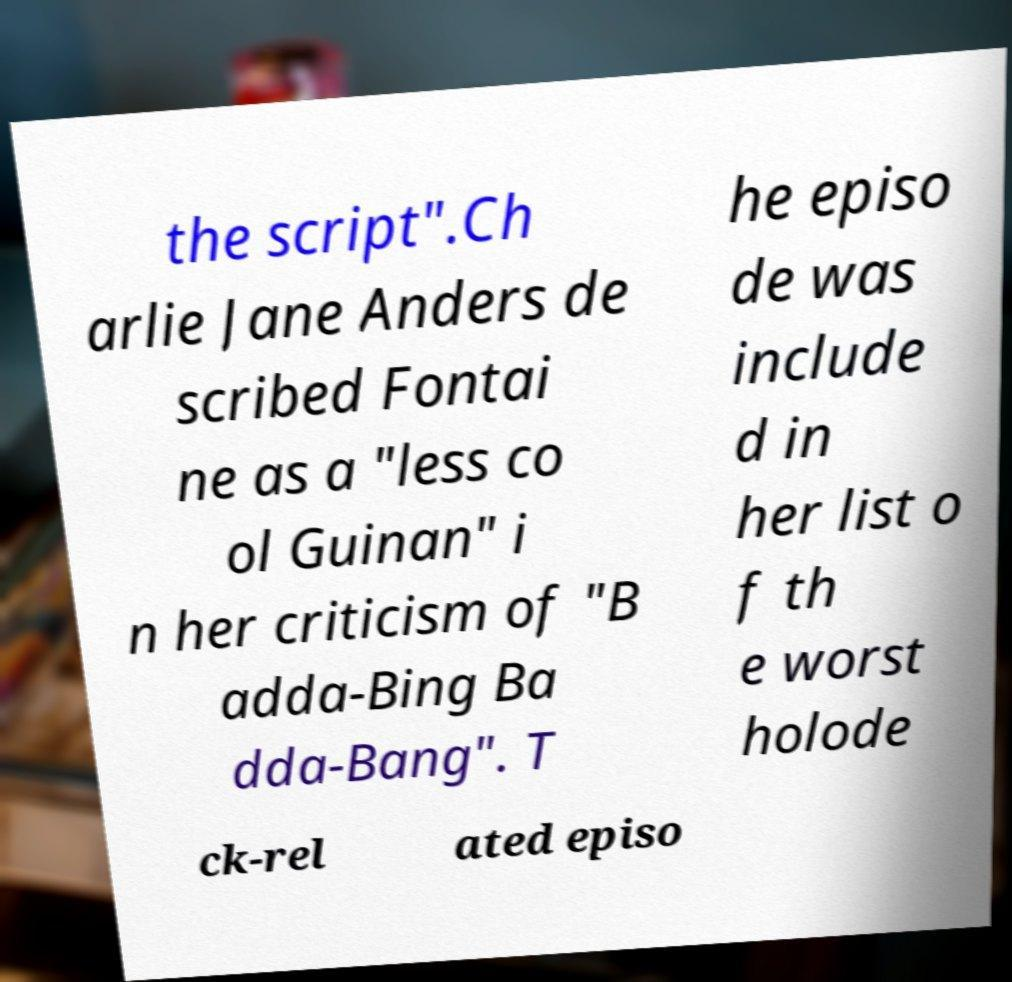What messages or text are displayed in this image? I need them in a readable, typed format. the script".Ch arlie Jane Anders de scribed Fontai ne as a "less co ol Guinan" i n her criticism of "B adda-Bing Ba dda-Bang". T he episo de was include d in her list o f th e worst holode ck-rel ated episo 